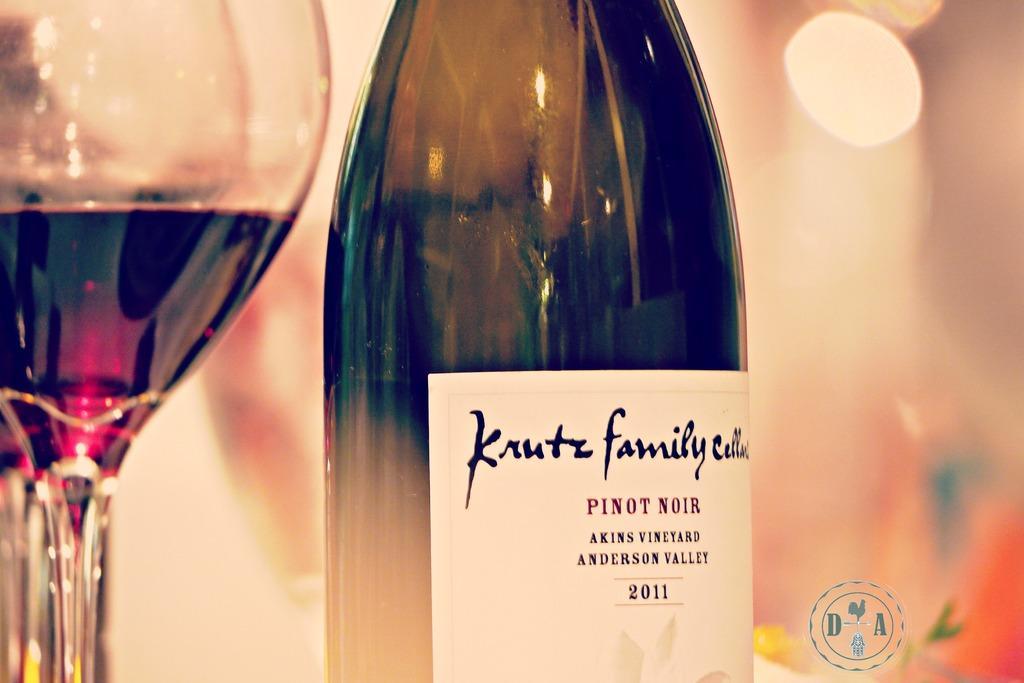Please provide a concise description of this image. In this image I can see a wine bottle and glass of drink. Background is colorful. 